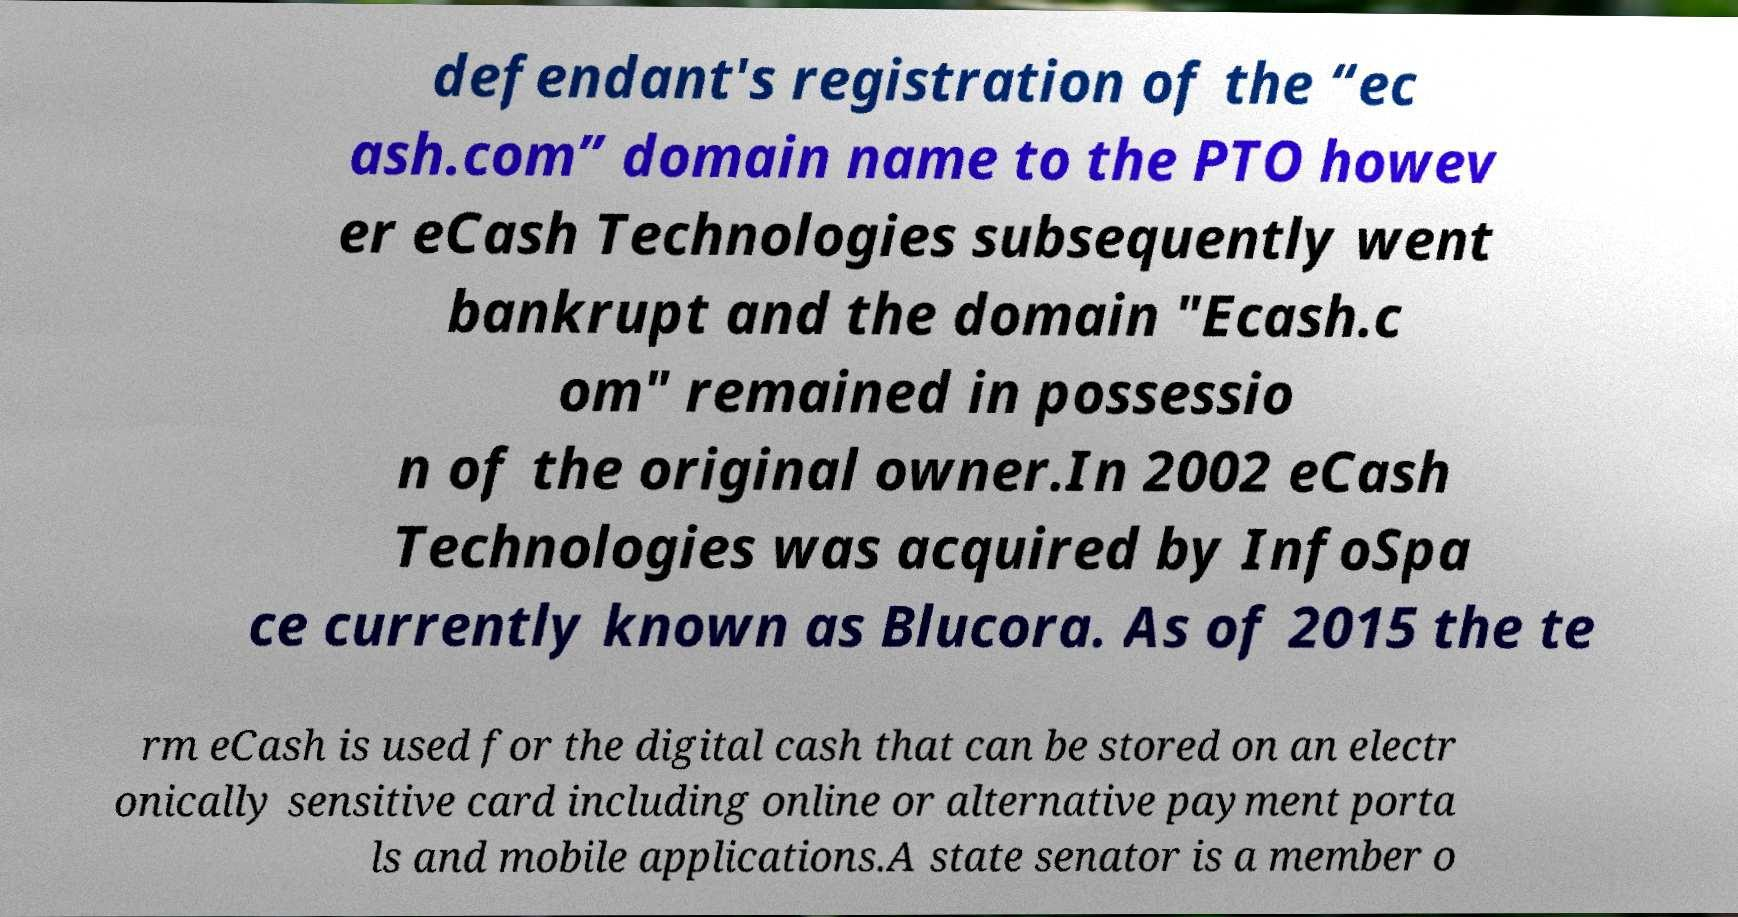Could you assist in decoding the text presented in this image and type it out clearly? defendant's registration of the “ec ash.com” domain name to the PTO howev er eCash Technologies subsequently went bankrupt and the domain "Ecash.c om" remained in possessio n of the original owner.In 2002 eCash Technologies was acquired by InfoSpa ce currently known as Blucora. As of 2015 the te rm eCash is used for the digital cash that can be stored on an electr onically sensitive card including online or alternative payment porta ls and mobile applications.A state senator is a member o 